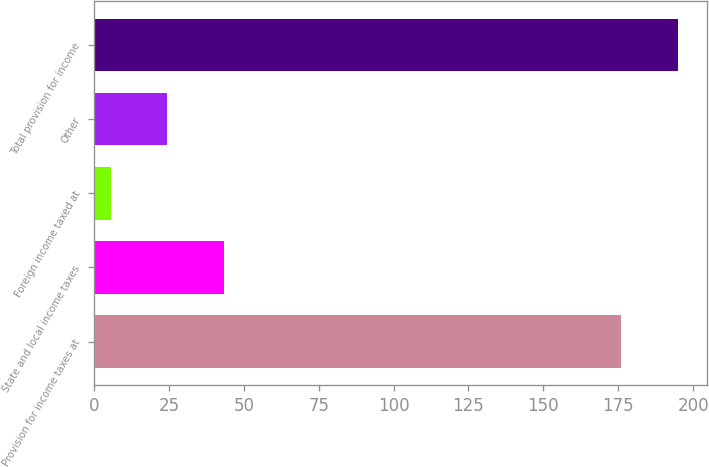Convert chart. <chart><loc_0><loc_0><loc_500><loc_500><bar_chart><fcel>Provision for income taxes at<fcel>State and local income taxes<fcel>Foreign income taxed at<fcel>Other<fcel>Total provision for income<nl><fcel>176<fcel>43.46<fcel>5.6<fcel>24.53<fcel>194.93<nl></chart> 